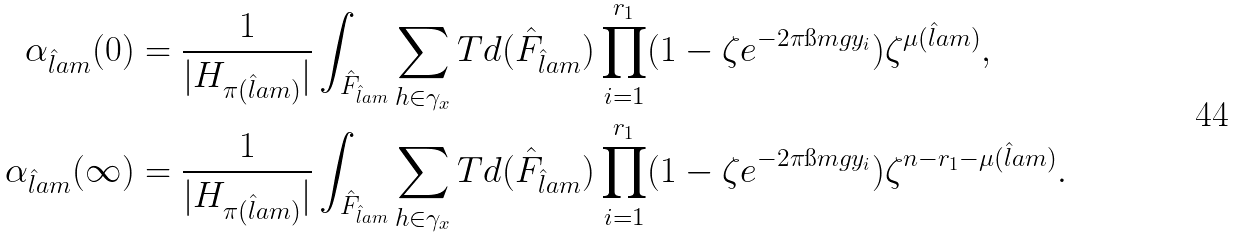<formula> <loc_0><loc_0><loc_500><loc_500>\alpha _ { \hat { l } a m } ( 0 ) & = \frac { 1 } { | H _ { \pi ( \hat { l } a m ) } | } \int _ { \hat { F } _ { \hat { l } a m } } \sum _ { h \in \gamma _ { x } } T d ( \hat { F } _ { \hat { l } a m } ) \prod _ { i = 1 } ^ { r _ { 1 } } ( 1 - \zeta e ^ { - 2 \pi \i m g y _ { i } } ) \zeta ^ { \mu ( \hat { l } a m ) } , \\ \alpha _ { \hat { l } a m } ( \infty ) & = \frac { 1 } { | H _ { \pi ( \hat { l } a m ) } | } \int _ { \hat { F } _ { \hat { l } a m } } \sum _ { h \in \gamma _ { x } } T d ( \hat { F } _ { \hat { l } a m } ) \prod _ { i = 1 } ^ { r _ { 1 } } ( 1 - \zeta e ^ { - 2 \pi \i m g y _ { i } } ) \zeta ^ { n - r _ { 1 } - \mu ( \hat { l } a m ) } .</formula> 